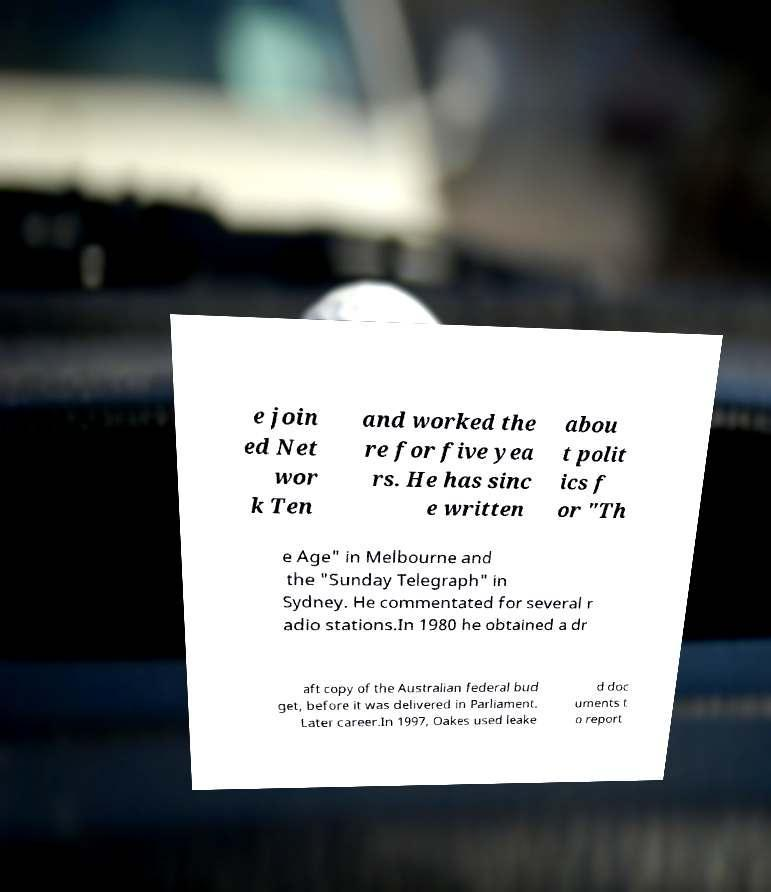Please identify and transcribe the text found in this image. e join ed Net wor k Ten and worked the re for five yea rs. He has sinc e written abou t polit ics f or "Th e Age" in Melbourne and the "Sunday Telegraph" in Sydney. He commentated for several r adio stations.In 1980 he obtained a dr aft copy of the Australian federal bud get, before it was delivered in Parliament. Later career.In 1997, Oakes used leake d doc uments t o report 